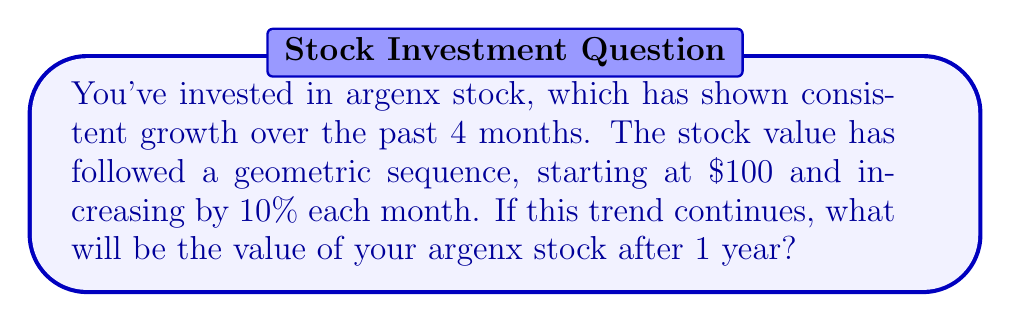Could you help me with this problem? Let's approach this step-by-step:

1) The initial value (a) is $100.
2) The common ratio (r) is 1.10, as it increases by 10% each month.
3) We need to find the 12th term in the sequence (n = 12 for 1 year).

The formula for the nth term of a geometric sequence is:
$$a_n = a \cdot r^{n-1}$$

Where:
$a_n$ is the nth term
$a$ is the initial value
$r$ is the common ratio
$n$ is the term number

Plugging in our values:
$$a_{12} = 100 \cdot (1.10)^{12-1}$$
$$a_{12} = 100 \cdot (1.10)^{11}$$

Using a calculator:
$$a_{12} = 100 \cdot 2.8531167061$$
$$a_{12} = 285.31167061$$

Rounding to the nearest cent:
$$a_{12} \approx 285.31$$
Answer: $285.31 